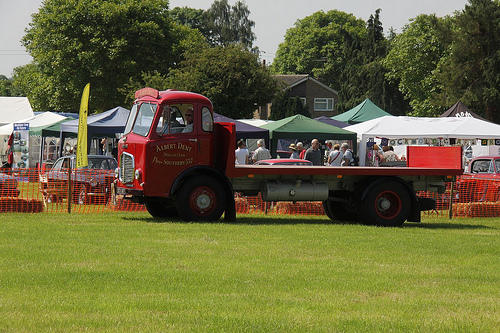<image>
Is there a truck on the grass? Yes. Looking at the image, I can see the truck is positioned on top of the grass, with the grass providing support. Where is the tent in relation to the truck? Is it behind the truck? Yes. From this viewpoint, the tent is positioned behind the truck, with the truck partially or fully occluding the tent. Where is the sky in relation to the tent? Is it behind the tent? Yes. From this viewpoint, the sky is positioned behind the tent, with the tent partially or fully occluding the sky. 